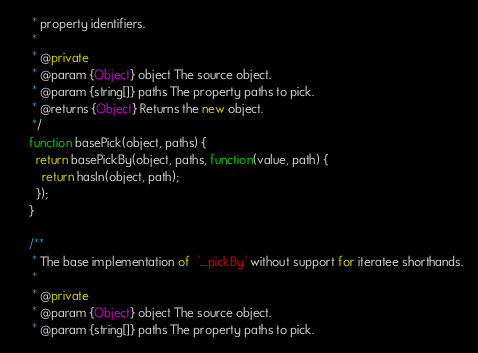<code> <loc_0><loc_0><loc_500><loc_500><_JavaScript_>     * property identifiers.
     *
     * @private
     * @param {Object} object The source object.
     * @param {string[]} paths The property paths to pick.
     * @returns {Object} Returns the new object.
     */
    function basePick(object, paths) {
      return basePickBy(object, paths, function(value, path) {
        return hasIn(object, path);
      });
    }

    /**
     * The base implementation of  `_.pickBy` without support for iteratee shorthands.
     *
     * @private
     * @param {Object} object The source object.
     * @param {string[]} paths The property paths to pick.</code> 